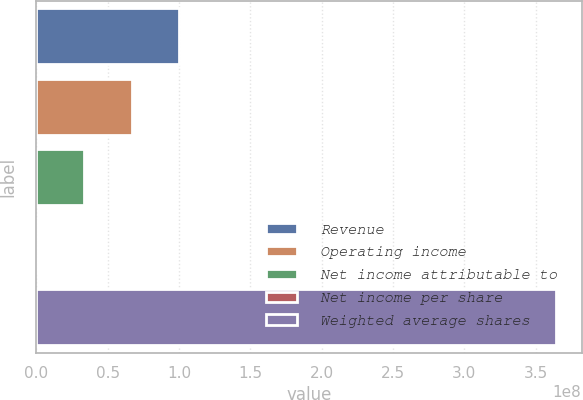Convert chart to OTSL. <chart><loc_0><loc_0><loc_500><loc_500><bar_chart><fcel>Revenue<fcel>Operating income<fcel>Net income attributable to<fcel>Net income per share<fcel>Weighted average shares<nl><fcel>1.00251e+08<fcel>6.68343e+07<fcel>3.34172e+07<fcel>1.28<fcel>3.64037e+08<nl></chart> 